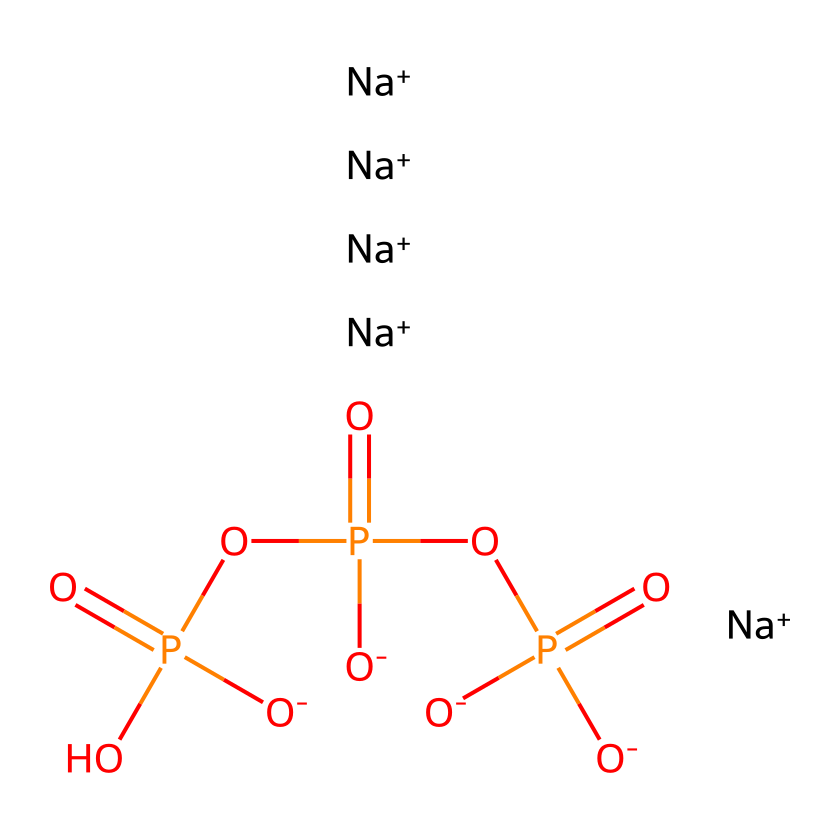What is the molecular formula for sodium tripolyphosphate? By analyzing the SMILES representation, we can deduce that the compound consists of sodium (Na), phosphorus (P), and oxygen (O) atoms. The breakdown indicates 5 sodium ions, 3 phosphorus atoms, and 10 oxygen atoms, leading to the molecular formula, Na5P3O10.
Answer: Na5P3O10 How many sodium ions are present in this compound? The SMILES representation shows five sodium ions denoted as [Na+]. Counting these directly gives us the number of sodium ions.
Answer: 5 What type of functional group is predominantly featured in sodium tripolyphosphate? Looking at the structure, the phosphate groups are central to the compound as they consist of phosphorus surrounded by oxygen. The -PO4 structure is characteristic of a phosphate functional group.
Answer: phosphate How does this compound function as a detergent? Sodium tripolyphosphate reduces water hardness by binding with calcium and magnesium ions, allowing detergents to work more effectively by preventing these ions from interfering with cleaning.
Answer: binding ions What is the total number of oxygen atoms in this compound? The SMILES shows a total of 10 oxygen atoms. This can be verified by counting the occurrences of the letter 'O' in the representation.
Answer: 10 Why is sodium tripolyphosphate classified as a phosphorus compound? This compound contains phosphorus atoms as part of its core structure in the phosphate groups, making it a member of phosphorus compounds categorized based on their phosphorus content.
Answer: phosphorus What role do phosphate groups play in the chemical's functionality? Phosphate groups facilitate ion interaction and binding, which is critical for the compound's effectiveness in promoting cleaning and preventing hardness in water.
Answer: ion interaction 